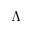<formula> <loc_0><loc_0><loc_500><loc_500>\Lambda</formula> 